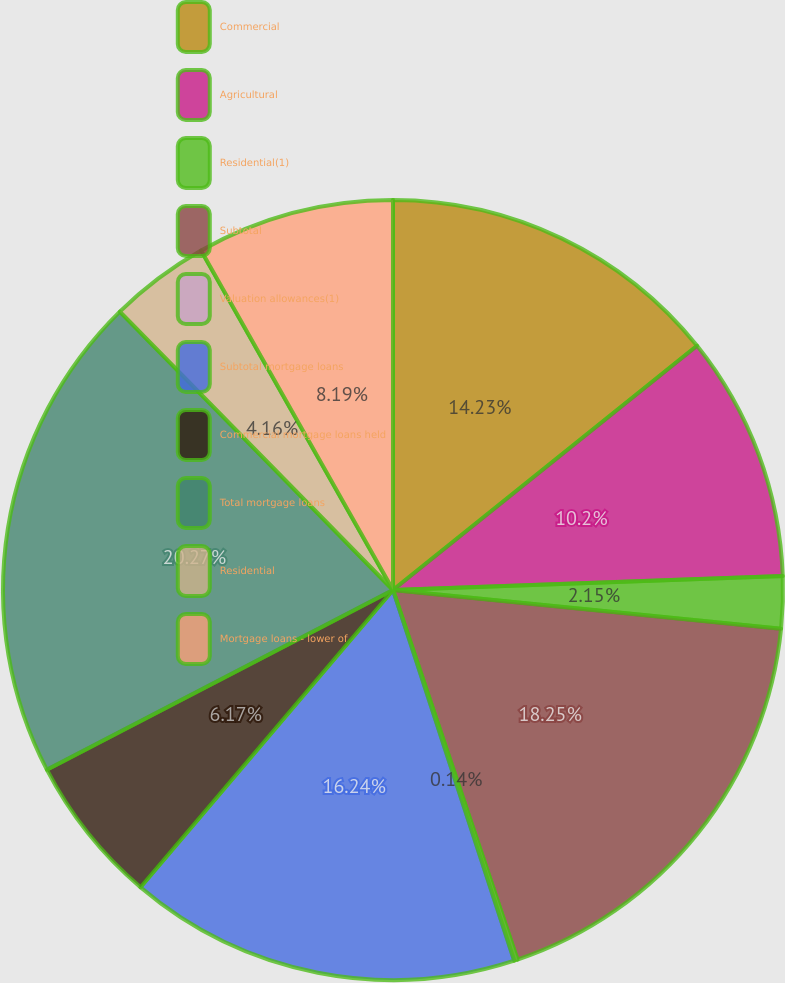<chart> <loc_0><loc_0><loc_500><loc_500><pie_chart><fcel>Commercial<fcel>Agricultural<fcel>Residential(1)<fcel>Subtotal<fcel>Valuation allowances(1)<fcel>Subtotal mortgage loans<fcel>Commercial mortgage loans held<fcel>Total mortgage loans<fcel>Residential<fcel>Mortgage loans - lower of<nl><fcel>14.23%<fcel>10.2%<fcel>2.15%<fcel>18.25%<fcel>0.14%<fcel>16.24%<fcel>6.17%<fcel>20.27%<fcel>4.16%<fcel>8.19%<nl></chart> 